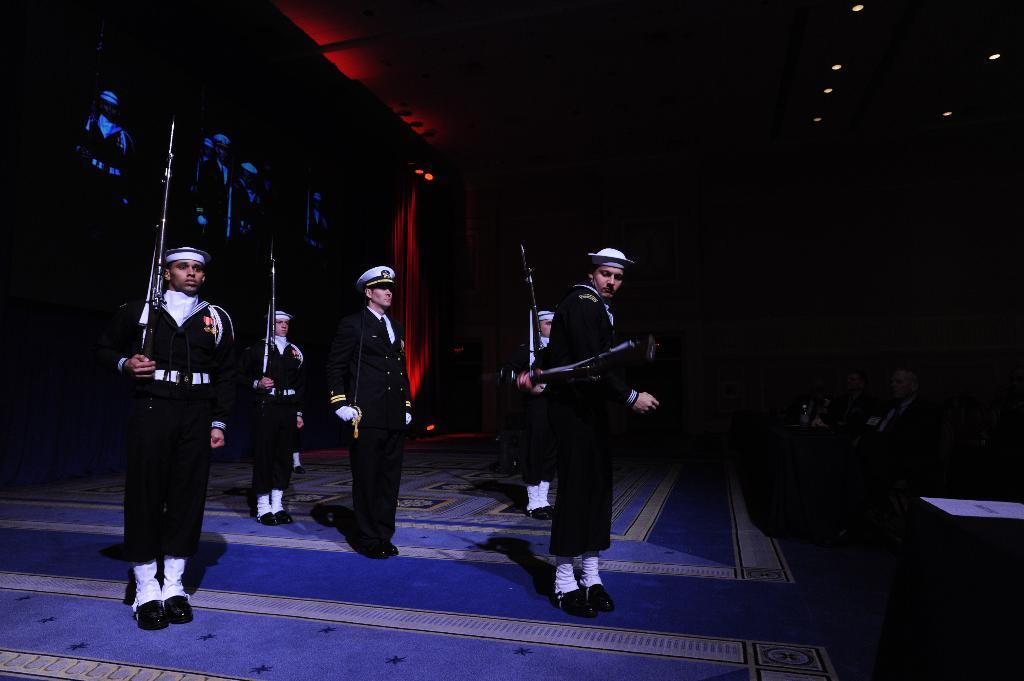How many people are in the image? There are persons in the image. What are the persons wearing? The persons are wearing the same dress. What are the persons holding in the image? The persons are holding guns. What can be seen at the top of the image? There are lights at the top of the image. How many roses are being held by the persons in the image? There are no roses present in the image; the persons are holding guns. Can you tell me the color of the snake in the image? There is no snake present in the image. 